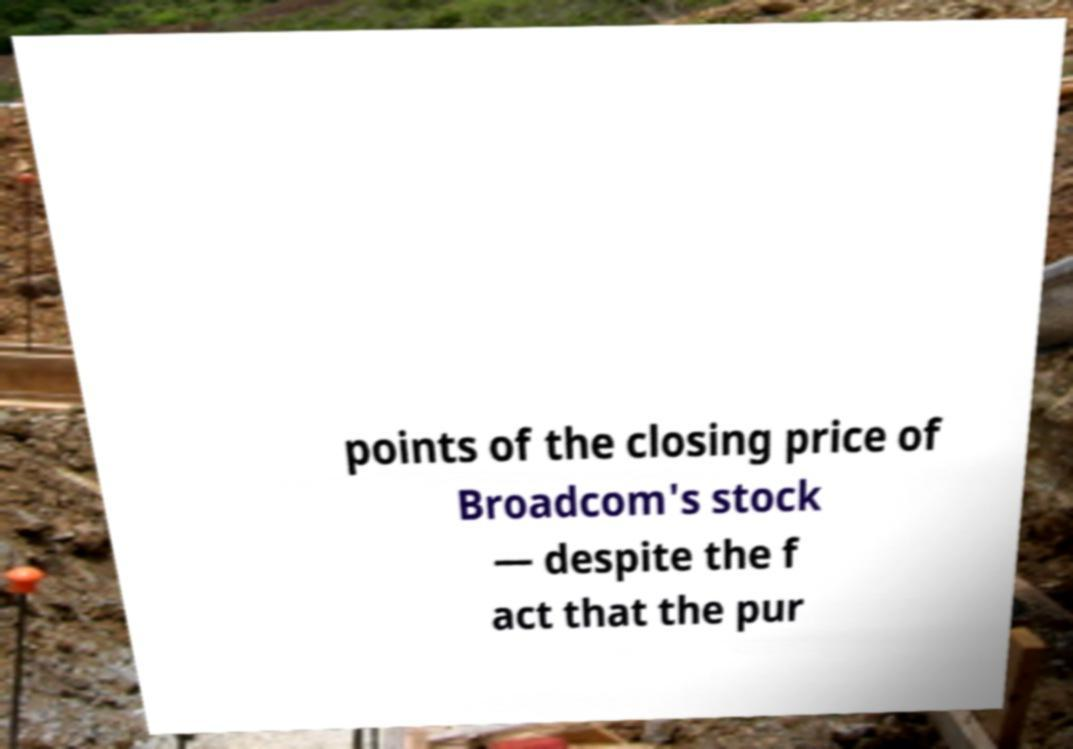What messages or text are displayed in this image? I need them in a readable, typed format. points of the closing price of Broadcom's stock — despite the f act that the pur 